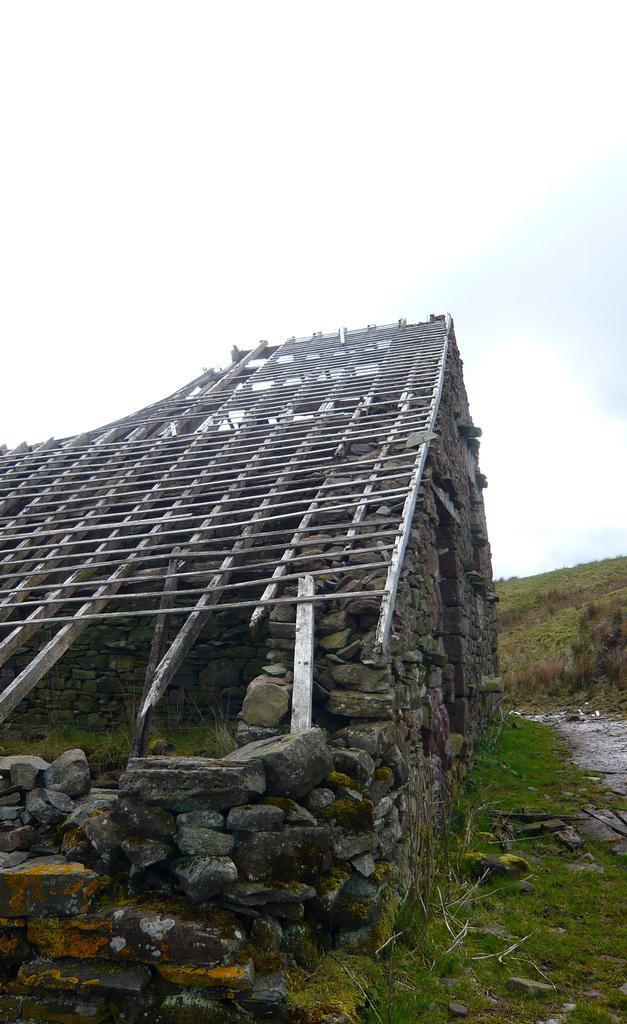In one or two sentences, can you explain what this image depicts? In this image there is a wooden structure on the rocks. At the bottom of the image there is grass on the surface. In the background of the image there is sky. 